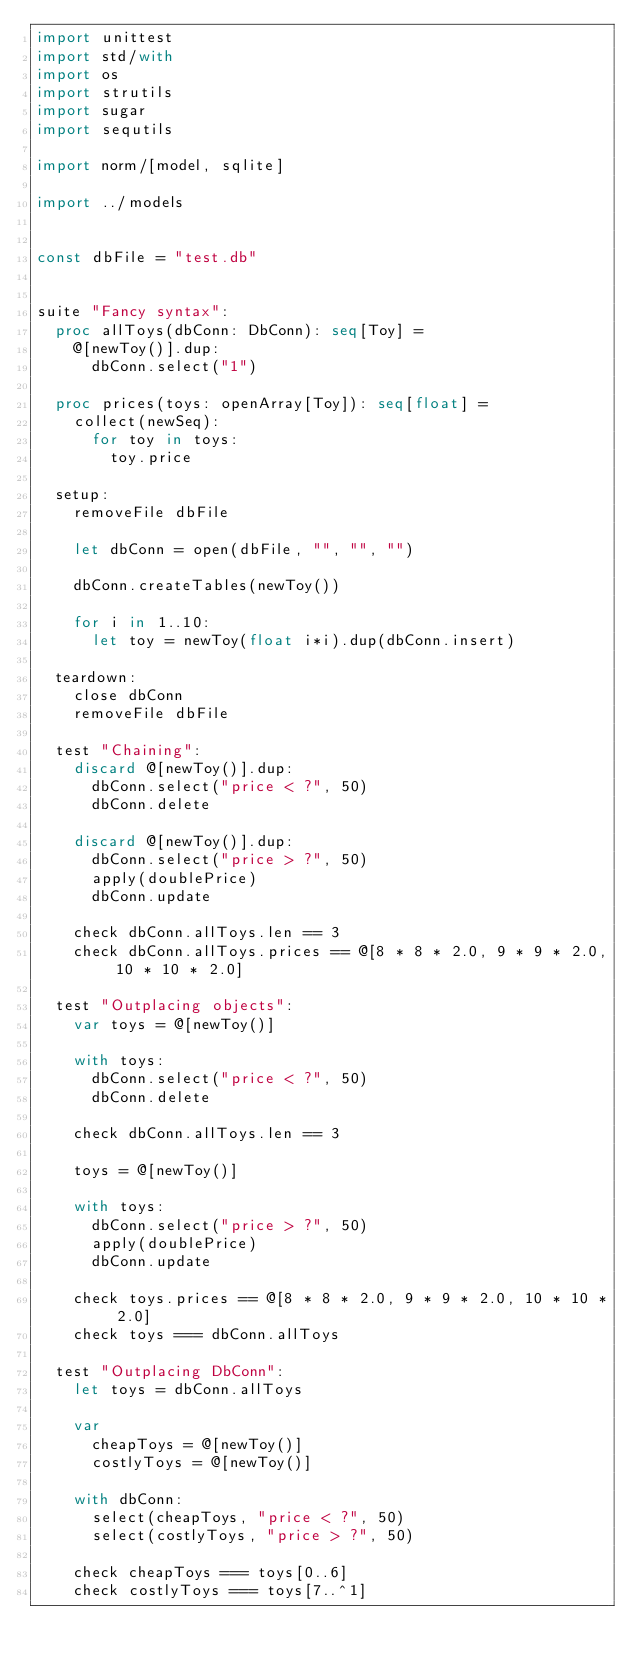Convert code to text. <code><loc_0><loc_0><loc_500><loc_500><_Nim_>import unittest
import std/with
import os
import strutils
import sugar
import sequtils

import norm/[model, sqlite]

import ../models


const dbFile = "test.db"


suite "Fancy syntax":
  proc allToys(dbConn: DbConn): seq[Toy] =
    @[newToy()].dup:
      dbConn.select("1")

  proc prices(toys: openArray[Toy]): seq[float] =
    collect(newSeq):
      for toy in toys:
        toy.price

  setup:
    removeFile dbFile

    let dbConn = open(dbFile, "", "", "")

    dbConn.createTables(newToy())

    for i in 1..10:
      let toy = newToy(float i*i).dup(dbConn.insert)

  teardown:
    close dbConn
    removeFile dbFile

  test "Chaining":
    discard @[newToy()].dup:
      dbConn.select("price < ?", 50)
      dbConn.delete

    discard @[newToy()].dup:
      dbConn.select("price > ?", 50)
      apply(doublePrice)
      dbConn.update

    check dbConn.allToys.len == 3
    check dbConn.allToys.prices == @[8 * 8 * 2.0, 9 * 9 * 2.0, 10 * 10 * 2.0]

  test "Outplacing objects":
    var toys = @[newToy()]

    with toys:
      dbConn.select("price < ?", 50)
      dbConn.delete

    check dbConn.allToys.len == 3

    toys = @[newToy()]

    with toys:
      dbConn.select("price > ?", 50)
      apply(doublePrice)
      dbConn.update

    check toys.prices == @[8 * 8 * 2.0, 9 * 9 * 2.0, 10 * 10 * 2.0]
    check toys === dbConn.allToys

  test "Outplacing DbConn":
    let toys = dbConn.allToys

    var
      cheapToys = @[newToy()]
      costlyToys = @[newToy()]

    with dbConn:
      select(cheapToys, "price < ?", 50)
      select(costlyToys, "price > ?", 50)

    check cheapToys === toys[0..6]
    check costlyToys === toys[7..^1]
</code> 